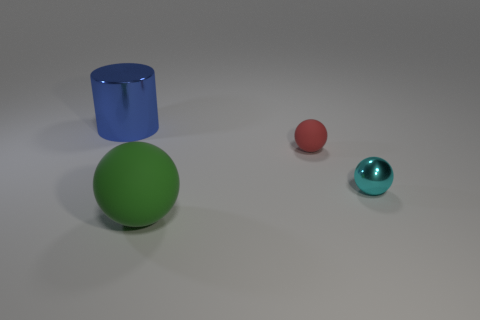What shape is the large blue shiny thing that is behind the small sphere behind the small cyan thing?
Your response must be concise. Cylinder. Are there any balls that have the same material as the red object?
Offer a terse response. Yes. What is the big thing right of the blue metal thing made of?
Give a very brief answer. Rubber. What is the material of the small cyan ball?
Ensure brevity in your answer.  Metal. Does the big thing that is behind the green object have the same material as the red sphere?
Your response must be concise. No. Is the number of red matte balls that are in front of the large rubber object less than the number of brown things?
Offer a terse response. No. There is a thing that is the same size as the cylinder; what is its color?
Make the answer very short. Green. How many tiny rubber things are the same shape as the cyan metallic object?
Provide a succinct answer. 1. What is the color of the matte object in front of the small cyan metal thing?
Ensure brevity in your answer.  Green. How many matte things are green spheres or blue objects?
Keep it short and to the point. 1. 